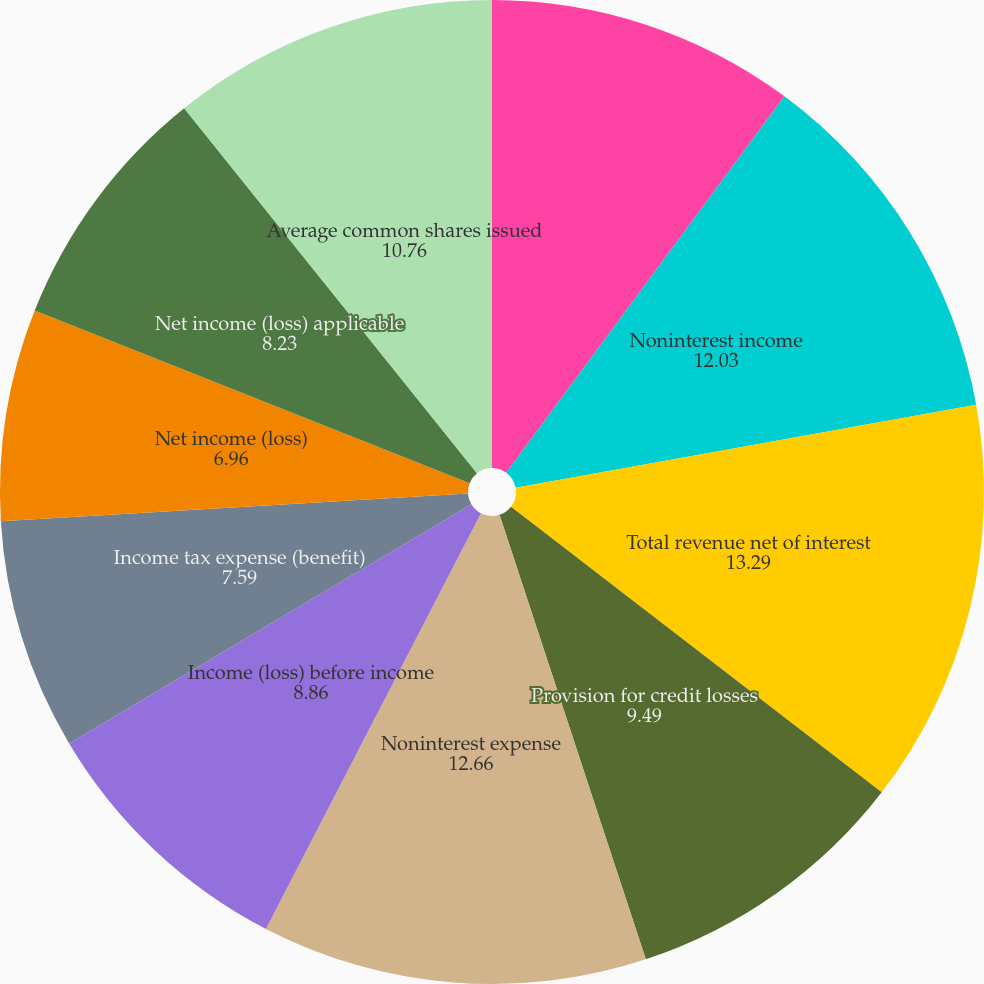<chart> <loc_0><loc_0><loc_500><loc_500><pie_chart><fcel>Net interest income<fcel>Noninterest income<fcel>Total revenue net of interest<fcel>Provision for credit losses<fcel>Noninterest expense<fcel>Income (loss) before income<fcel>Income tax expense (benefit)<fcel>Net income (loss)<fcel>Net income (loss) applicable<fcel>Average common shares issued<nl><fcel>10.13%<fcel>12.03%<fcel>13.29%<fcel>9.49%<fcel>12.66%<fcel>8.86%<fcel>7.59%<fcel>6.96%<fcel>8.23%<fcel>10.76%<nl></chart> 